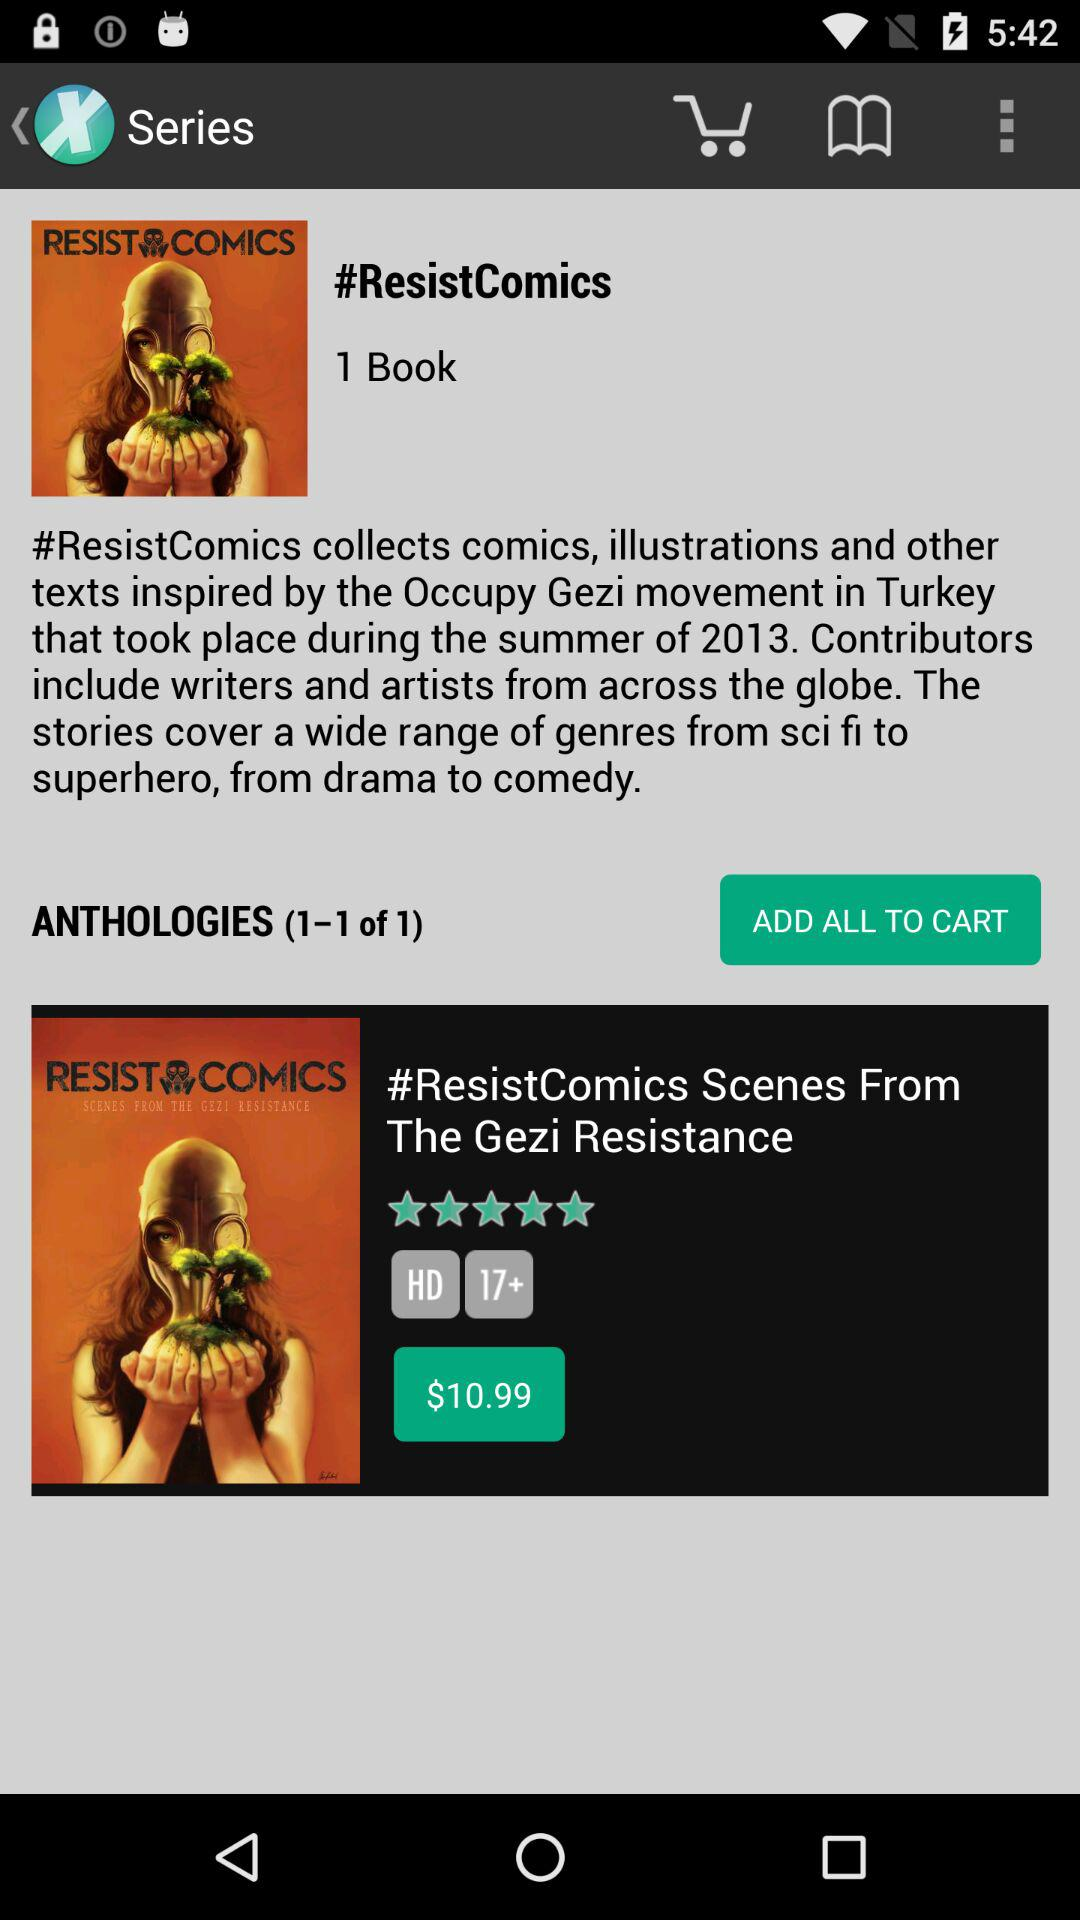How much is the book?
Answer the question using a single word or phrase. $10.99 